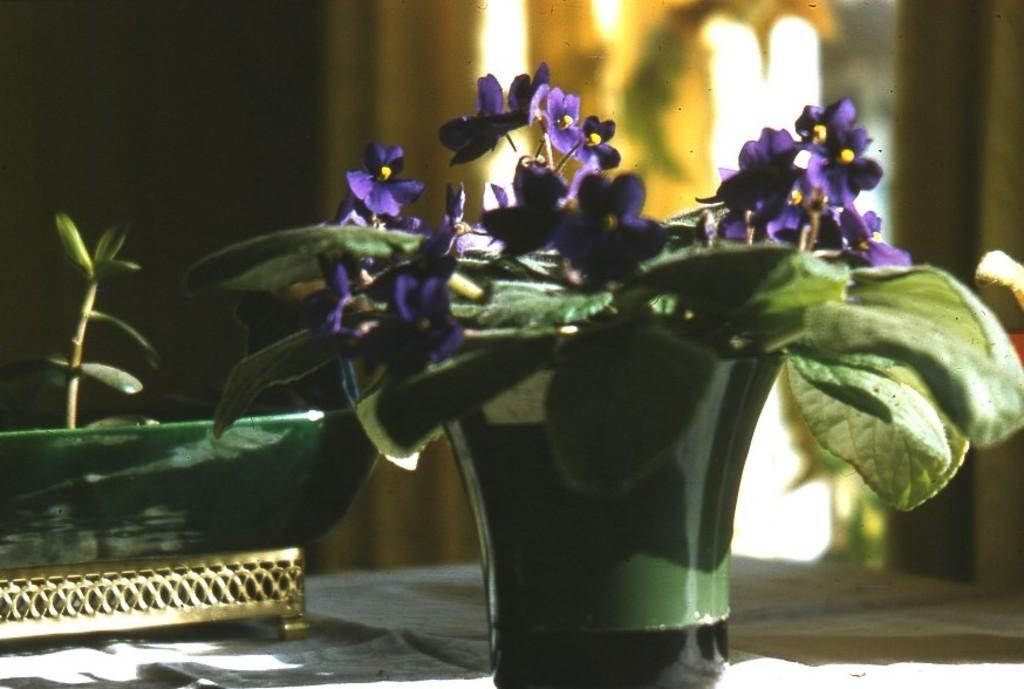What is placed on the table in the image? There is a flower plant on a table. Can you describe the surroundings of the table? There is another plant visible behind the table. What type of wing can be seen on the flower plant in the image? There are no wings present on the flower plant in the image. 